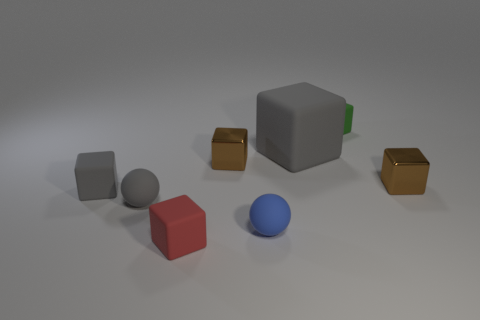Subtract all tiny shiny cubes. How many cubes are left? 4 Subtract all purple cylinders. How many brown cubes are left? 2 Add 1 gray rubber spheres. How many objects exist? 9 Subtract 3 cubes. How many cubes are left? 3 Subtract all red cubes. How many cubes are left? 5 Subtract all blocks. How many objects are left? 2 Add 6 small brown metal objects. How many small brown metal objects are left? 8 Add 8 blue rubber balls. How many blue rubber balls exist? 9 Subtract 1 red cubes. How many objects are left? 7 Subtract all green spheres. Subtract all cyan cylinders. How many spheres are left? 2 